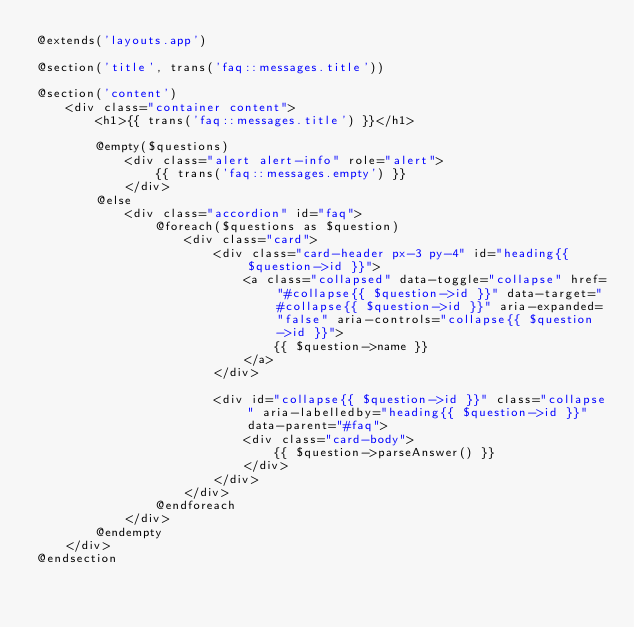<code> <loc_0><loc_0><loc_500><loc_500><_PHP_>@extends('layouts.app')

@section('title', trans('faq::messages.title'))

@section('content')
    <div class="container content">
        <h1>{{ trans('faq::messages.title') }}</h1>

        @empty($questions)
            <div class="alert alert-info" role="alert">
                {{ trans('faq::messages.empty') }}
            </div>
        @else
            <div class="accordion" id="faq">
                @foreach($questions as $question)
                    <div class="card">
                        <div class="card-header px-3 py-4" id="heading{{ $question->id }}">
                            <a class="collapsed" data-toggle="collapse" href="#collapse{{ $question->id }}" data-target="#collapse{{ $question->id }}" aria-expanded="false" aria-controls="collapse{{ $question->id }}">
                                {{ $question->name }}
                            </a>
                        </div>

                        <div id="collapse{{ $question->id }}" class="collapse" aria-labelledby="heading{{ $question->id }}" data-parent="#faq">
                            <div class="card-body">
                                {{ $question->parseAnswer() }}
                            </div>
                        </div>
                    </div>
                @endforeach
            </div>
        @endempty
    </div>
@endsection
</code> 